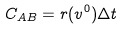Convert formula to latex. <formula><loc_0><loc_0><loc_500><loc_500>C _ { A B } = r ( v ^ { 0 } ) \Delta t</formula> 